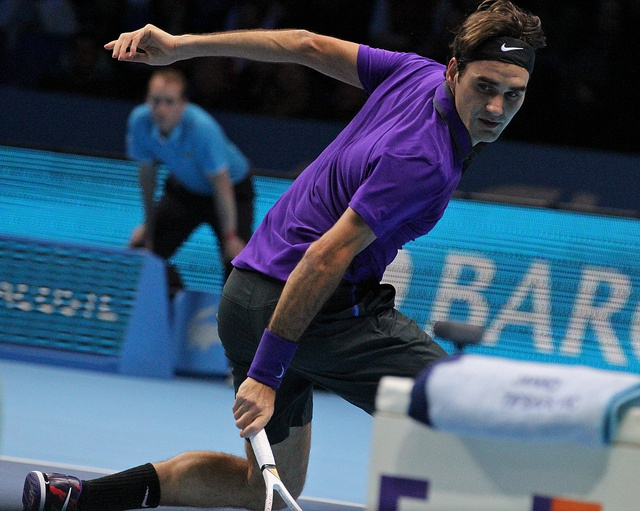Describe the objects in this image and their specific colors. I can see people in black, navy, gray, and purple tones, people in black, blue, and gray tones, and tennis racket in black, lightgray, gray, and darkgray tones in this image. 